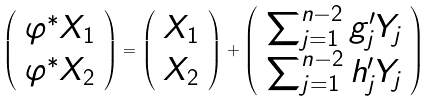<formula> <loc_0><loc_0><loc_500><loc_500>\left ( \begin{array} { c } \varphi ^ { * } X _ { 1 } \\ \varphi ^ { * } X _ { 2 } \end{array} \right ) = \left ( \begin{array} { c } X _ { 1 } \\ X _ { 2 } \end{array} \right ) + \left ( \begin{array} { c } \sum _ { j = 1 } ^ { n - 2 } g _ { j } ^ { \prime } Y _ { j } \\ \sum _ { j = 1 } ^ { n - 2 } h _ { j } ^ { \prime } Y _ { j } \end{array} \right )</formula> 